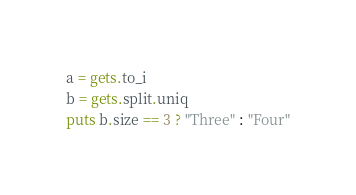<code> <loc_0><loc_0><loc_500><loc_500><_Ruby_>a = gets.to_i
b = gets.split.uniq
puts b.size == 3 ? "Three" : "Four"</code> 